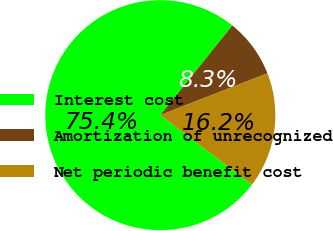Convert chart to OTSL. <chart><loc_0><loc_0><loc_500><loc_500><pie_chart><fcel>Interest cost<fcel>Amortization of unrecognized<fcel>Net periodic benefit cost<nl><fcel>75.45%<fcel>8.3%<fcel>16.25%<nl></chart> 